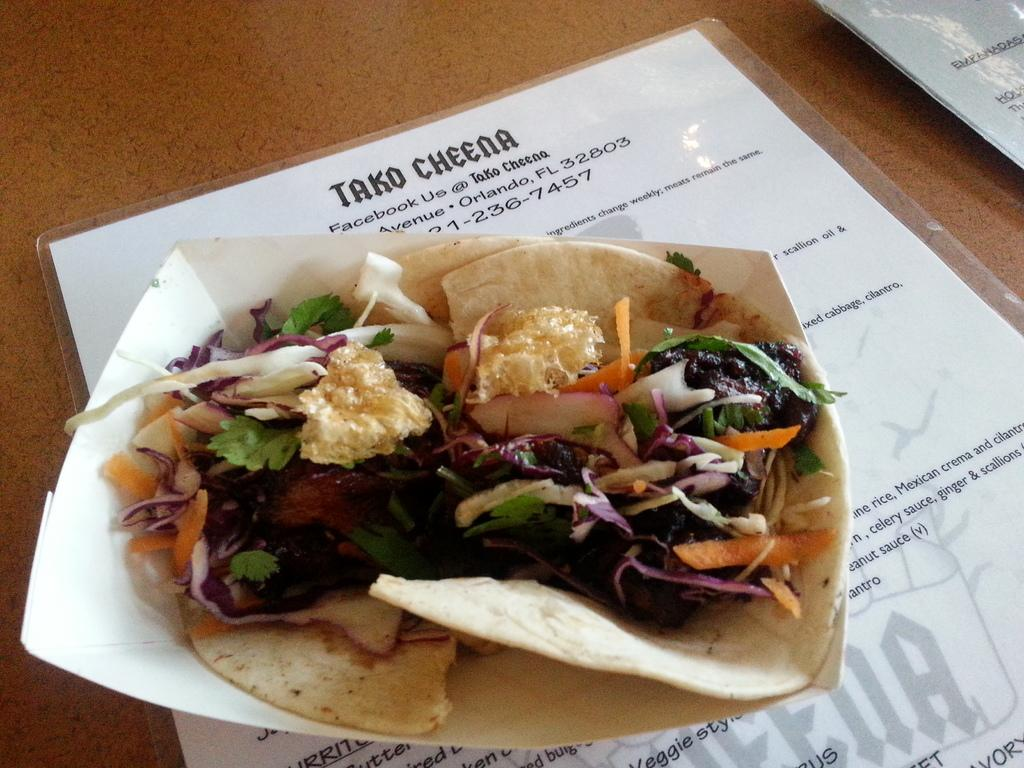What is present on the plate in the image? The food items are placed on a plate in the image. How is the plate positioned in relation to the menu card? The plate is placed on a menu card in the image. What is the income of the person who created the ground in the image? There is no mention of a person creating the ground in the image, nor is there any information about income. 